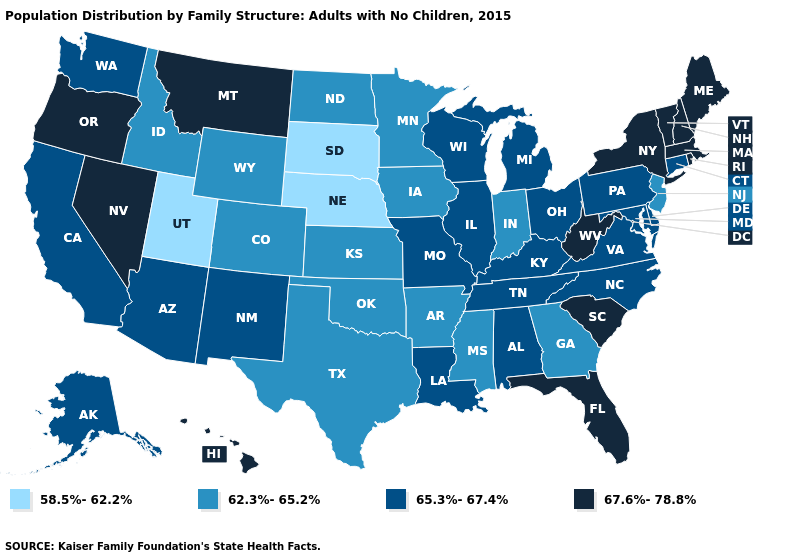Among the states that border Wyoming , does Utah have the lowest value?
Keep it brief. Yes. What is the highest value in the West ?
Short answer required. 67.6%-78.8%. Name the states that have a value in the range 58.5%-62.2%?
Be succinct. Nebraska, South Dakota, Utah. What is the value of Idaho?
Be succinct. 62.3%-65.2%. Does Utah have the lowest value in the USA?
Concise answer only. Yes. Name the states that have a value in the range 62.3%-65.2%?
Short answer required. Arkansas, Colorado, Georgia, Idaho, Indiana, Iowa, Kansas, Minnesota, Mississippi, New Jersey, North Dakota, Oklahoma, Texas, Wyoming. Does South Dakota have the lowest value in the MidWest?
Answer briefly. Yes. Does Rhode Island have the same value as California?
Concise answer only. No. Does Utah have the lowest value in the USA?
Write a very short answer. Yes. What is the value of Delaware?
Give a very brief answer. 65.3%-67.4%. What is the value of Indiana?
Give a very brief answer. 62.3%-65.2%. Name the states that have a value in the range 62.3%-65.2%?
Short answer required. Arkansas, Colorado, Georgia, Idaho, Indiana, Iowa, Kansas, Minnesota, Mississippi, New Jersey, North Dakota, Oklahoma, Texas, Wyoming. Does Connecticut have the highest value in the USA?
Quick response, please. No. What is the highest value in states that border Vermont?
Quick response, please. 67.6%-78.8%. What is the lowest value in the USA?
Keep it brief. 58.5%-62.2%. 